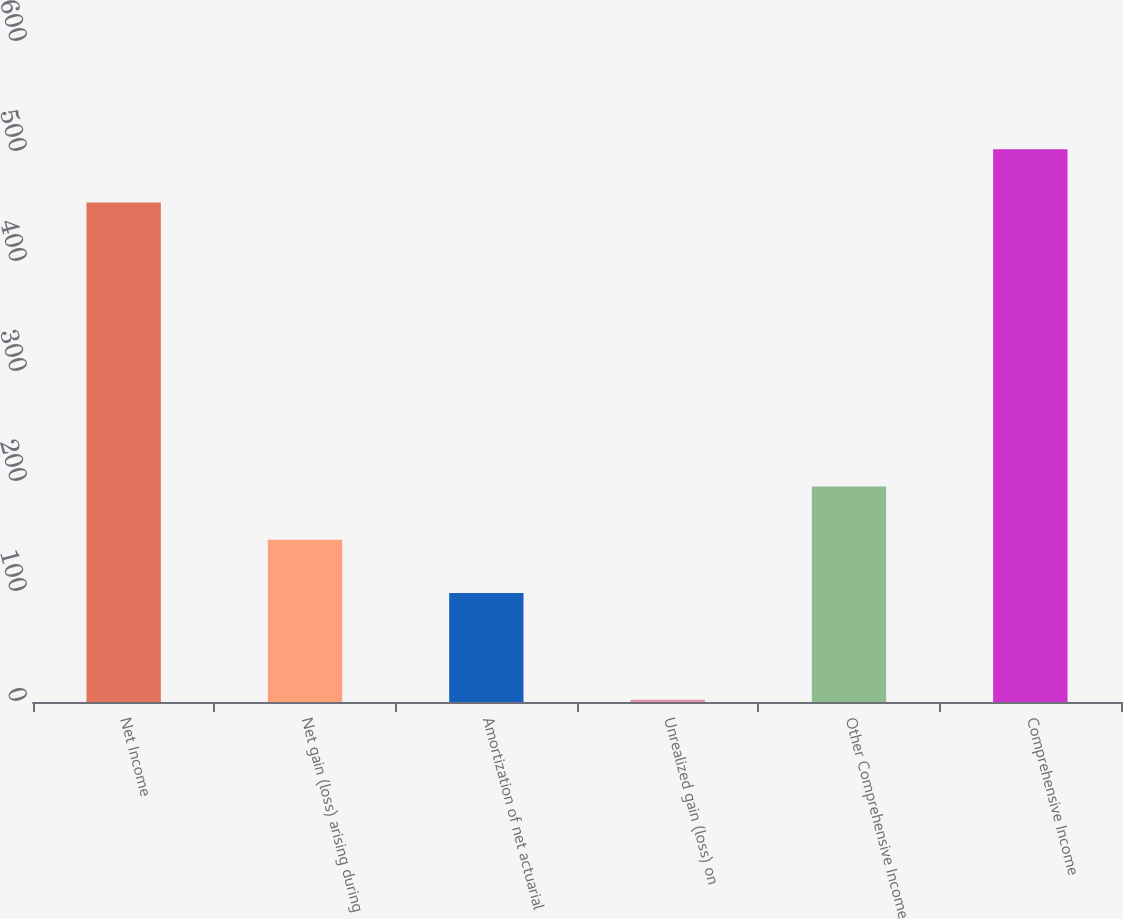Convert chart. <chart><loc_0><loc_0><loc_500><loc_500><bar_chart><fcel>Net Income<fcel>Net gain (loss) arising during<fcel>Amortization of net actuarial<fcel>Unrealized gain (loss) on<fcel>Other Comprehensive Income<fcel>Comprehensive Income<nl><fcel>454<fcel>147.5<fcel>99<fcel>2<fcel>196<fcel>502.5<nl></chart> 